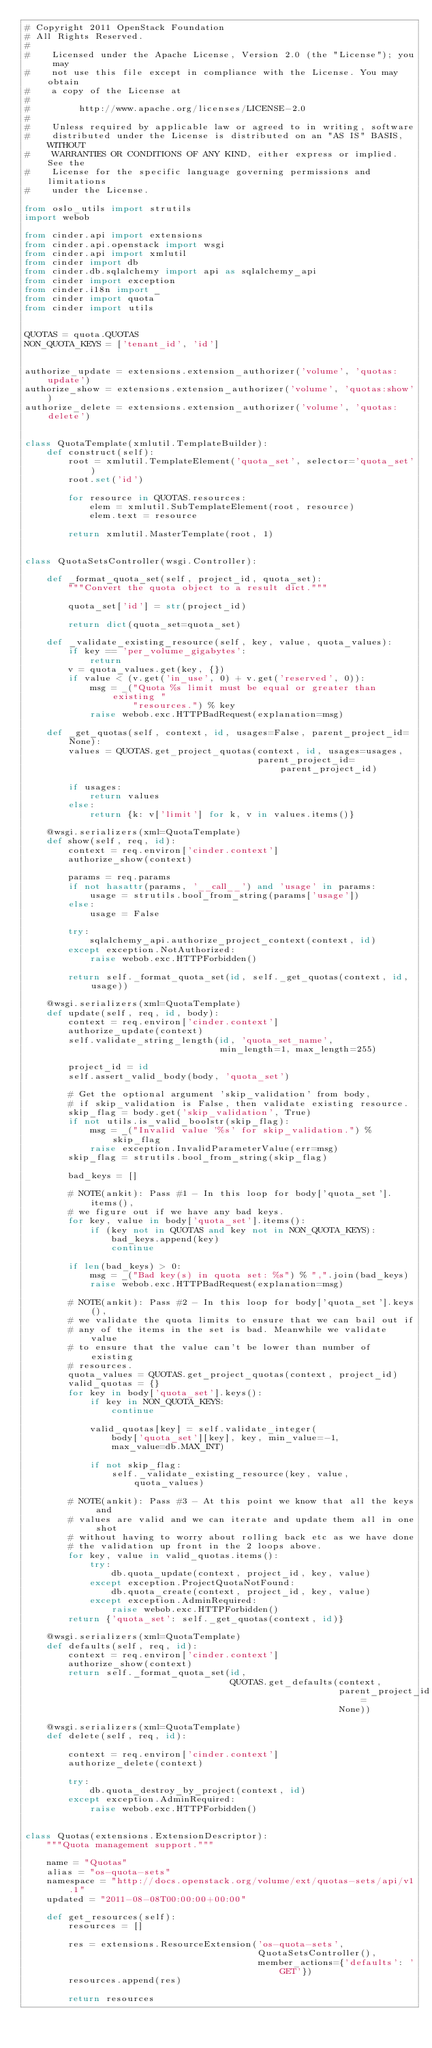Convert code to text. <code><loc_0><loc_0><loc_500><loc_500><_Python_># Copyright 2011 OpenStack Foundation
# All Rights Reserved.
#
#    Licensed under the Apache License, Version 2.0 (the "License"); you may
#    not use this file except in compliance with the License. You may obtain
#    a copy of the License at
#
#         http://www.apache.org/licenses/LICENSE-2.0
#
#    Unless required by applicable law or agreed to in writing, software
#    distributed under the License is distributed on an "AS IS" BASIS, WITHOUT
#    WARRANTIES OR CONDITIONS OF ANY KIND, either express or implied. See the
#    License for the specific language governing permissions and limitations
#    under the License.

from oslo_utils import strutils
import webob

from cinder.api import extensions
from cinder.api.openstack import wsgi
from cinder.api import xmlutil
from cinder import db
from cinder.db.sqlalchemy import api as sqlalchemy_api
from cinder import exception
from cinder.i18n import _
from cinder import quota
from cinder import utils


QUOTAS = quota.QUOTAS
NON_QUOTA_KEYS = ['tenant_id', 'id']


authorize_update = extensions.extension_authorizer('volume', 'quotas:update')
authorize_show = extensions.extension_authorizer('volume', 'quotas:show')
authorize_delete = extensions.extension_authorizer('volume', 'quotas:delete')


class QuotaTemplate(xmlutil.TemplateBuilder):
    def construct(self):
        root = xmlutil.TemplateElement('quota_set', selector='quota_set')
        root.set('id')

        for resource in QUOTAS.resources:
            elem = xmlutil.SubTemplateElement(root, resource)
            elem.text = resource

        return xmlutil.MasterTemplate(root, 1)


class QuotaSetsController(wsgi.Controller):

    def _format_quota_set(self, project_id, quota_set):
        """Convert the quota object to a result dict."""

        quota_set['id'] = str(project_id)

        return dict(quota_set=quota_set)

    def _validate_existing_resource(self, key, value, quota_values):
        if key == 'per_volume_gigabytes':
            return
        v = quota_values.get(key, {})
        if value < (v.get('in_use', 0) + v.get('reserved', 0)):
            msg = _("Quota %s limit must be equal or greater than existing "
                    "resources.") % key
            raise webob.exc.HTTPBadRequest(explanation=msg)

    def _get_quotas(self, context, id, usages=False, parent_project_id=None):
        values = QUOTAS.get_project_quotas(context, id, usages=usages,
                                           parent_project_id=parent_project_id)

        if usages:
            return values
        else:
            return {k: v['limit'] for k, v in values.items()}

    @wsgi.serializers(xml=QuotaTemplate)
    def show(self, req, id):
        context = req.environ['cinder.context']
        authorize_show(context)

        params = req.params
        if not hasattr(params, '__call__') and 'usage' in params:
            usage = strutils.bool_from_string(params['usage'])
        else:
            usage = False

        try:
            sqlalchemy_api.authorize_project_context(context, id)
        except exception.NotAuthorized:
            raise webob.exc.HTTPForbidden()

        return self._format_quota_set(id, self._get_quotas(context, id, usage))

    @wsgi.serializers(xml=QuotaTemplate)
    def update(self, req, id, body):
        context = req.environ['cinder.context']
        authorize_update(context)
        self.validate_string_length(id, 'quota_set_name',
                                    min_length=1, max_length=255)

        project_id = id
        self.assert_valid_body(body, 'quota_set')

        # Get the optional argument 'skip_validation' from body,
        # if skip_validation is False, then validate existing resource.
        skip_flag = body.get('skip_validation', True)
        if not utils.is_valid_boolstr(skip_flag):
            msg = _("Invalid value '%s' for skip_validation.") % skip_flag
            raise exception.InvalidParameterValue(err=msg)
        skip_flag = strutils.bool_from_string(skip_flag)

        bad_keys = []

        # NOTE(ankit): Pass #1 - In this loop for body['quota_set'].items(),
        # we figure out if we have any bad keys.
        for key, value in body['quota_set'].items():
            if (key not in QUOTAS and key not in NON_QUOTA_KEYS):
                bad_keys.append(key)
                continue

        if len(bad_keys) > 0:
            msg = _("Bad key(s) in quota set: %s") % ",".join(bad_keys)
            raise webob.exc.HTTPBadRequest(explanation=msg)

        # NOTE(ankit): Pass #2 - In this loop for body['quota_set'].keys(),
        # we validate the quota limits to ensure that we can bail out if
        # any of the items in the set is bad. Meanwhile we validate value
        # to ensure that the value can't be lower than number of existing
        # resources.
        quota_values = QUOTAS.get_project_quotas(context, project_id)
        valid_quotas = {}
        for key in body['quota_set'].keys():
            if key in NON_QUOTA_KEYS:
                continue

            valid_quotas[key] = self.validate_integer(
                body['quota_set'][key], key, min_value=-1,
                max_value=db.MAX_INT)

            if not skip_flag:
                self._validate_existing_resource(key, value, quota_values)

        # NOTE(ankit): Pass #3 - At this point we know that all the keys and
        # values are valid and we can iterate and update them all in one shot
        # without having to worry about rolling back etc as we have done
        # the validation up front in the 2 loops above.
        for key, value in valid_quotas.items():
            try:
                db.quota_update(context, project_id, key, value)
            except exception.ProjectQuotaNotFound:
                db.quota_create(context, project_id, key, value)
            except exception.AdminRequired:
                raise webob.exc.HTTPForbidden()
        return {'quota_set': self._get_quotas(context, id)}

    @wsgi.serializers(xml=QuotaTemplate)
    def defaults(self, req, id):
        context = req.environ['cinder.context']
        authorize_show(context)
        return self._format_quota_set(id,
                                      QUOTAS.get_defaults(context,
                                                          parent_project_id=
                                                          None))

    @wsgi.serializers(xml=QuotaTemplate)
    def delete(self, req, id):

        context = req.environ['cinder.context']
        authorize_delete(context)

        try:
            db.quota_destroy_by_project(context, id)
        except exception.AdminRequired:
            raise webob.exc.HTTPForbidden()


class Quotas(extensions.ExtensionDescriptor):
    """Quota management support."""

    name = "Quotas"
    alias = "os-quota-sets"
    namespace = "http://docs.openstack.org/volume/ext/quotas-sets/api/v1.1"
    updated = "2011-08-08T00:00:00+00:00"

    def get_resources(self):
        resources = []

        res = extensions.ResourceExtension('os-quota-sets',
                                           QuotaSetsController(),
                                           member_actions={'defaults': 'GET'})
        resources.append(res)

        return resources
</code> 